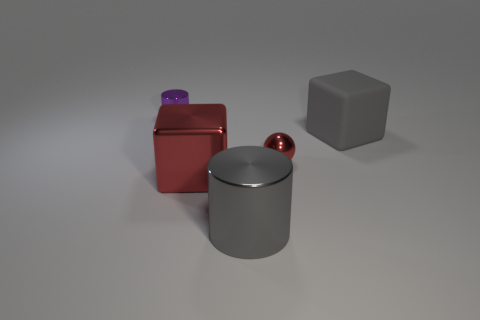Is there any other thing that is the same material as the big cylinder?
Provide a short and direct response. Yes. How many small objects are either matte cubes or green cylinders?
Your response must be concise. 0. Is the shape of the small shiny object on the right side of the purple metal object the same as  the small purple shiny object?
Keep it short and to the point. No. Is the number of large purple cylinders less than the number of red blocks?
Your response must be concise. Yes. Is there anything else that is the same color as the large rubber thing?
Provide a short and direct response. Yes. There is a large gray thing that is in front of the big red cube; what is its shape?
Provide a short and direct response. Cylinder. Do the big matte cube and the cube that is to the left of the large gray cylinder have the same color?
Your response must be concise. No. Are there an equal number of big gray objects that are in front of the tiny sphere and tiny red metallic spheres on the left side of the small purple shiny object?
Offer a very short reply. No. What number of other things are the same size as the gray shiny cylinder?
Provide a succinct answer. 2. The red sphere has what size?
Your answer should be very brief. Small. 